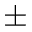Convert formula to latex. <formula><loc_0><loc_0><loc_500><loc_500>\pm</formula> 